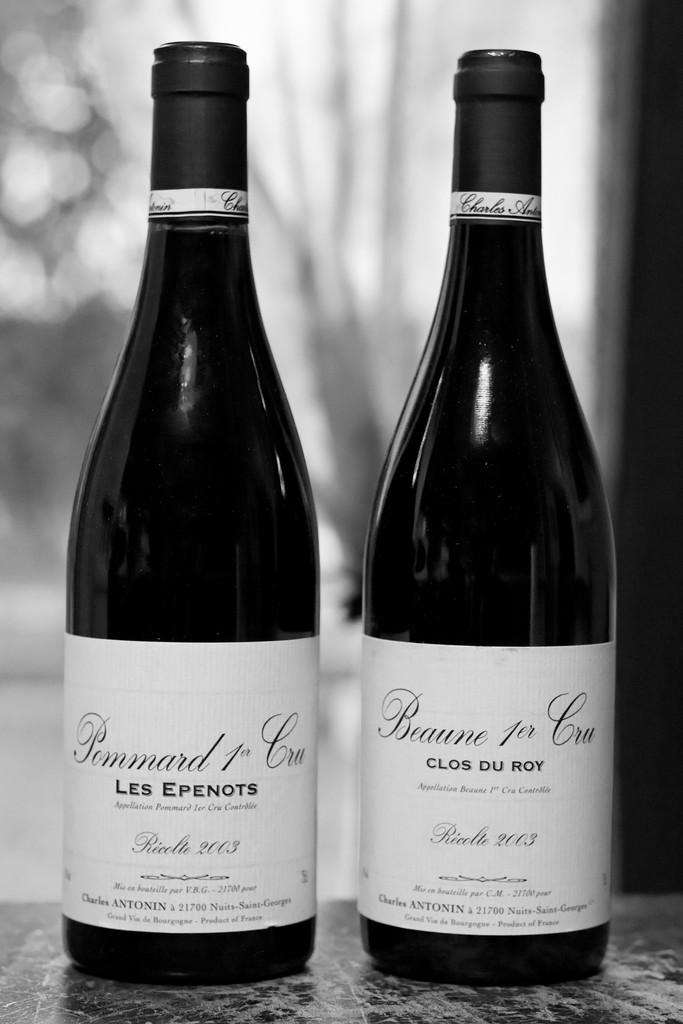Provide a one-sentence caption for the provided image. two bottles of Ricolte 2003 wine on a marble table. 